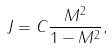<formula> <loc_0><loc_0><loc_500><loc_500>J = C \frac { M ^ { 2 } } { 1 - M ^ { 2 } } ,</formula> 